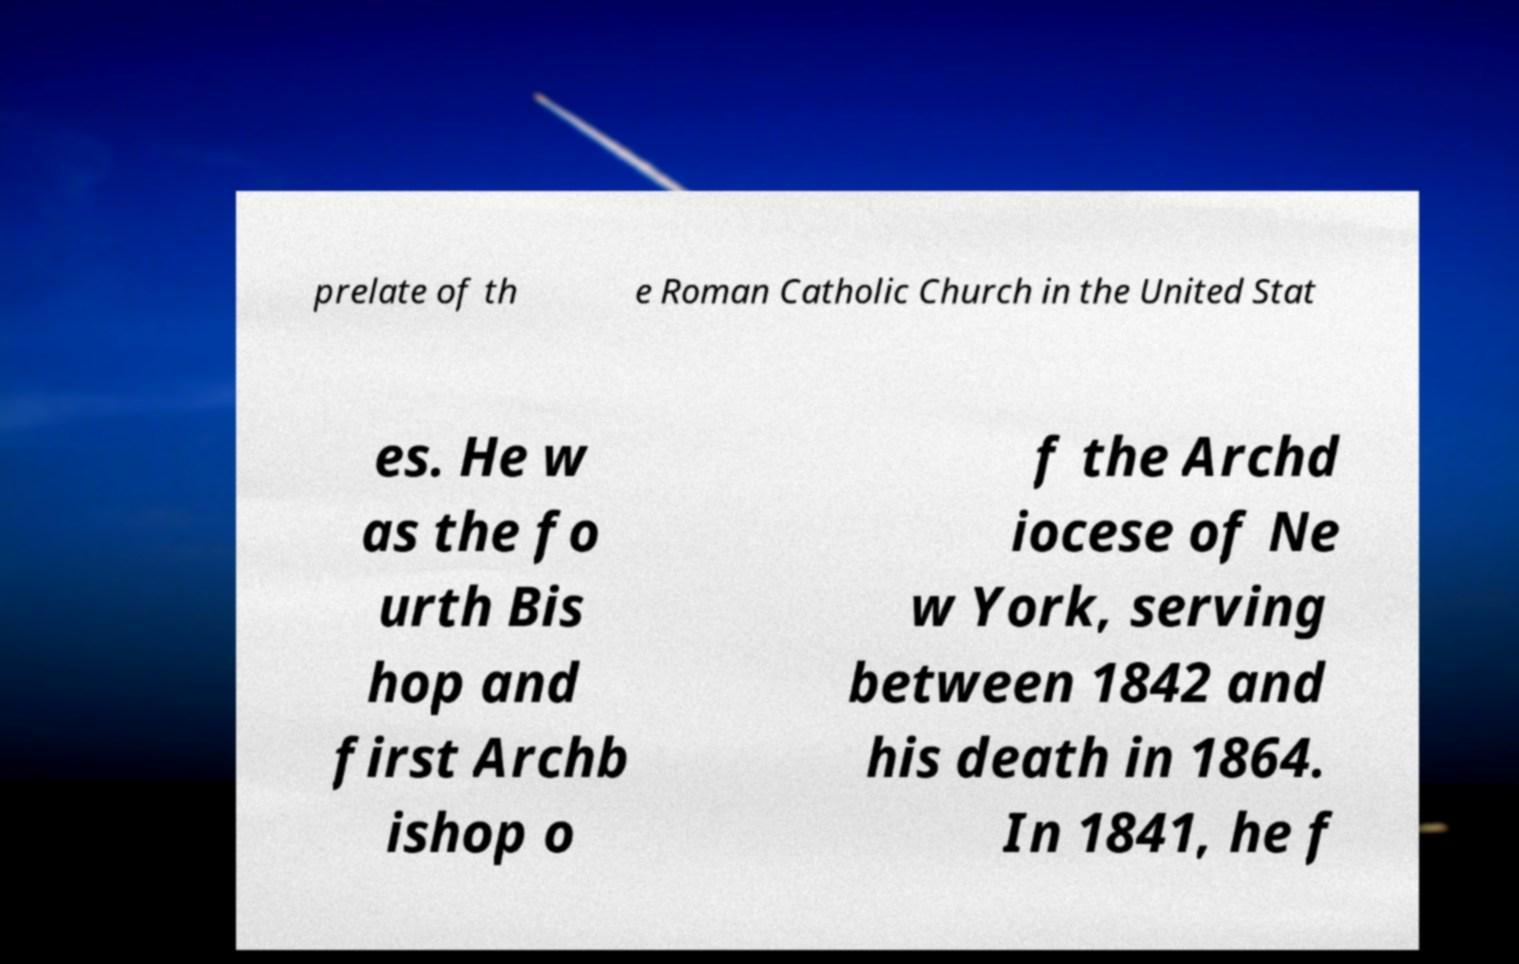There's text embedded in this image that I need extracted. Can you transcribe it verbatim? prelate of th e Roman Catholic Church in the United Stat es. He w as the fo urth Bis hop and first Archb ishop o f the Archd iocese of Ne w York, serving between 1842 and his death in 1864. In 1841, he f 